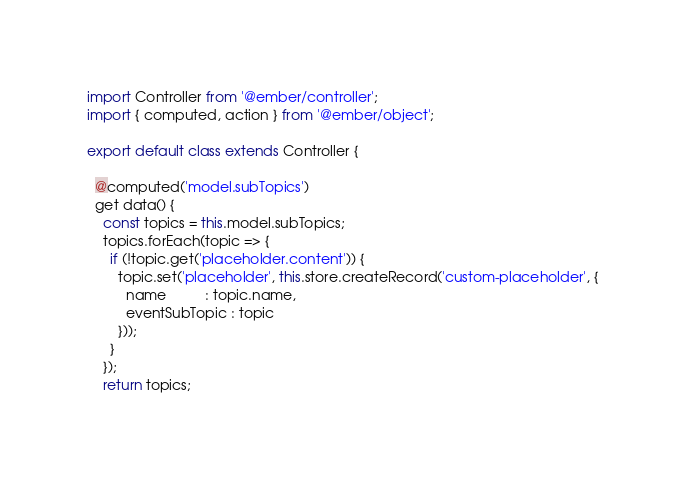<code> <loc_0><loc_0><loc_500><loc_500><_JavaScript_>import Controller from '@ember/controller';
import { computed, action } from '@ember/object';

export default class extends Controller {

  @computed('model.subTopics')
  get data() {
    const topics = this.model.subTopics;
    topics.forEach(topic => {
      if (!topic.get('placeholder.content')) {
        topic.set('placeholder', this.store.createRecord('custom-placeholder', {
          name          : topic.name,
          eventSubTopic : topic
        }));
      }
    });
    return topics;</code> 